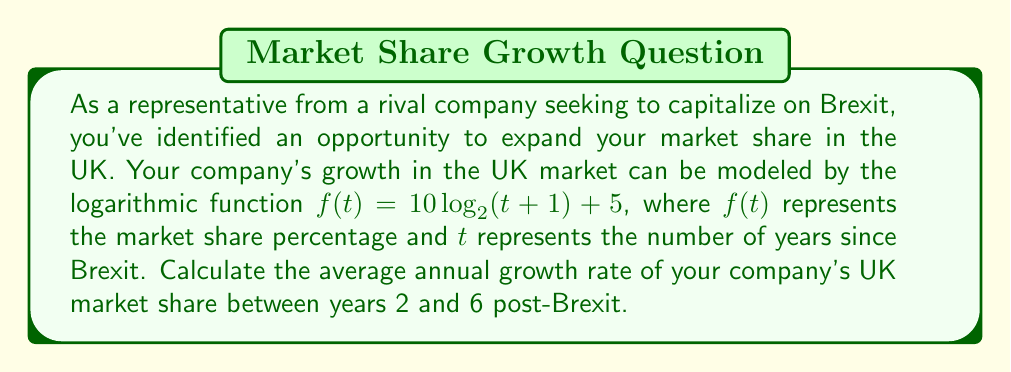Can you solve this math problem? To solve this problem, we'll follow these steps:

1) First, let's calculate the market share at years 2 and 6:

   For $t = 2$: $f(2) = 10 \log_2(2+1) + 5 = 10 \log_2(3) + 5 = 10 \cdot 1.585 + 5 = 20.85\%$
   For $t = 6$: $f(6) = 10 \log_2(6+1) + 5 = 10 \log_2(7) + 5 = 10 \cdot 2.807 + 5 = 33.07\%$

2) Now, we need to calculate the total growth rate over these 4 years:

   $\text{Total growth rate} = \frac{f(6) - f(2)}{f(2)} = \frac{33.07 - 20.85}{20.85} = 0.5861 = 58.61\%$

3) To find the average annual growth rate, we need to use the compound annual growth rate (CAGR) formula:

   $\text{CAGR} = (1 + r)^n - 1$

   Where $r$ is the annual growth rate we're looking for, and $n$ is the number of years (4 in this case).

4) Substituting our values:

   $0.5861 = (1 + r)^4 - 1$

5) Solving for $r$:

   $1.5861 = (1 + r)^4$
   $\sqrt[4]{1.5861} = 1 + r$
   $r = \sqrt[4]{1.5861} - 1 = 1.1226 - 1 = 0.1226$

6) Convert to percentage:

   $r = 0.1226 = 12.26\%$

Therefore, the average annual growth rate is approximately 12.26%.
Answer: The average annual growth rate of the company's UK market share between years 2 and 6 post-Brexit is approximately 12.26%. 